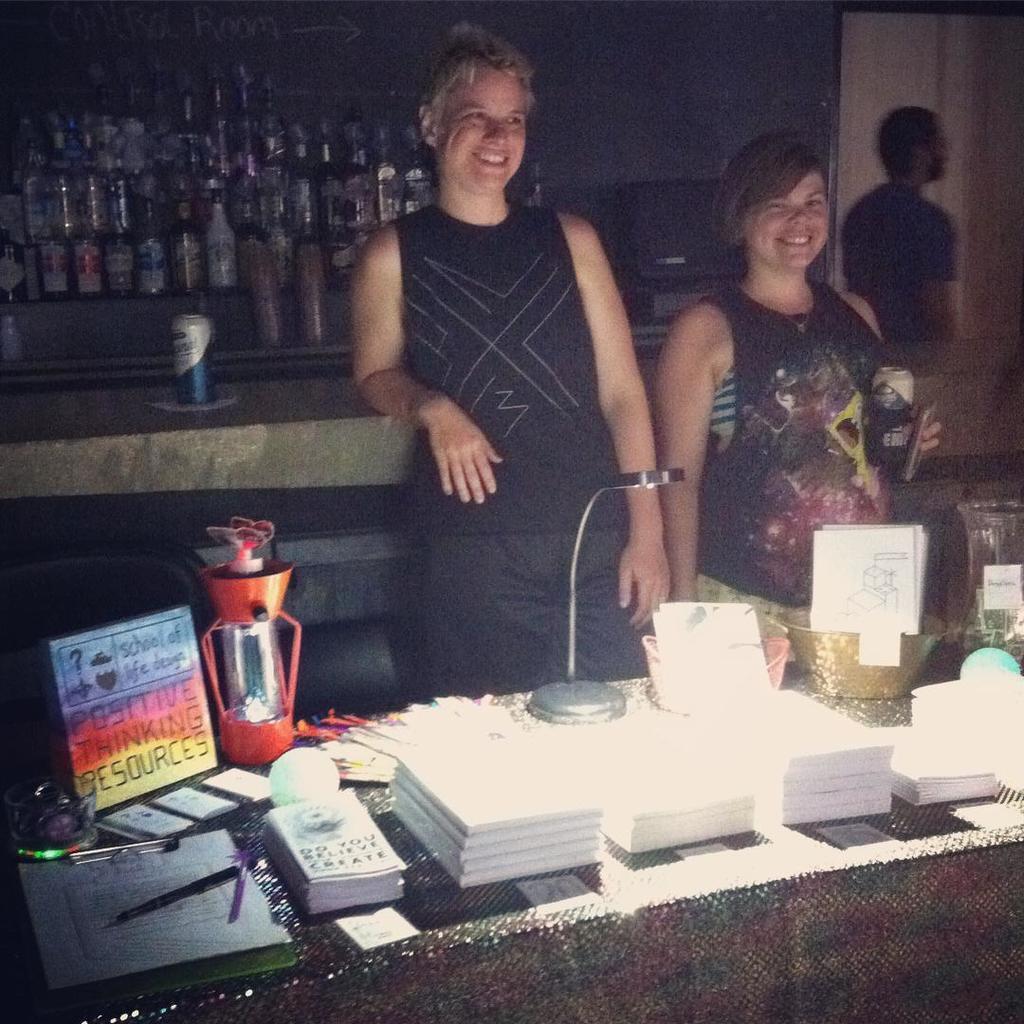Can you describe this image briefly? In the picture we can see two women are standing near to the desk, on the desk, we an see some things like papers, boxes and in the background also we can see a desk and bottles on it and we can also see a person standing. 